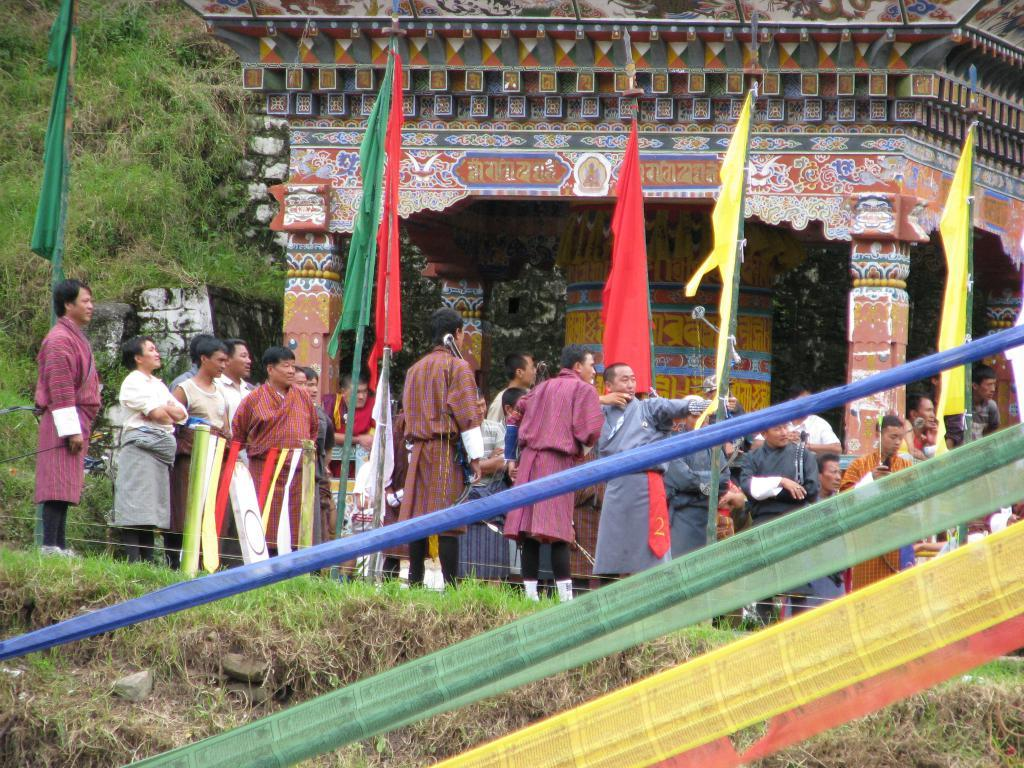Who or what can be seen in the image? There are people in the image. What objects are present in the image that might be related to a specific event or location? There are flags and poles in the image. What items are visible that might be related to daily life or personal belongings? There are clothes in the image. What type of structure is present in the image? There is a temple in the image. What type of natural elements can be seen in the image? There are plants and grass in the image. Can you tell me about the health of the lake in the image? There is no lake present in the image, so it is not possible to discuss its health. What type of request is being made by the people in the image? There is no indication of a request being made by the people in the image, as their actions or expressions are not described in the provided facts. 